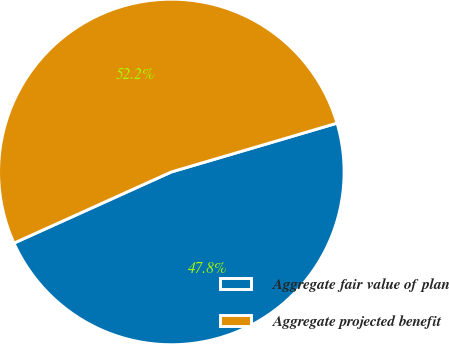<chart> <loc_0><loc_0><loc_500><loc_500><pie_chart><fcel>Aggregate fair value of plan<fcel>Aggregate projected benefit<nl><fcel>47.8%<fcel>52.2%<nl></chart> 